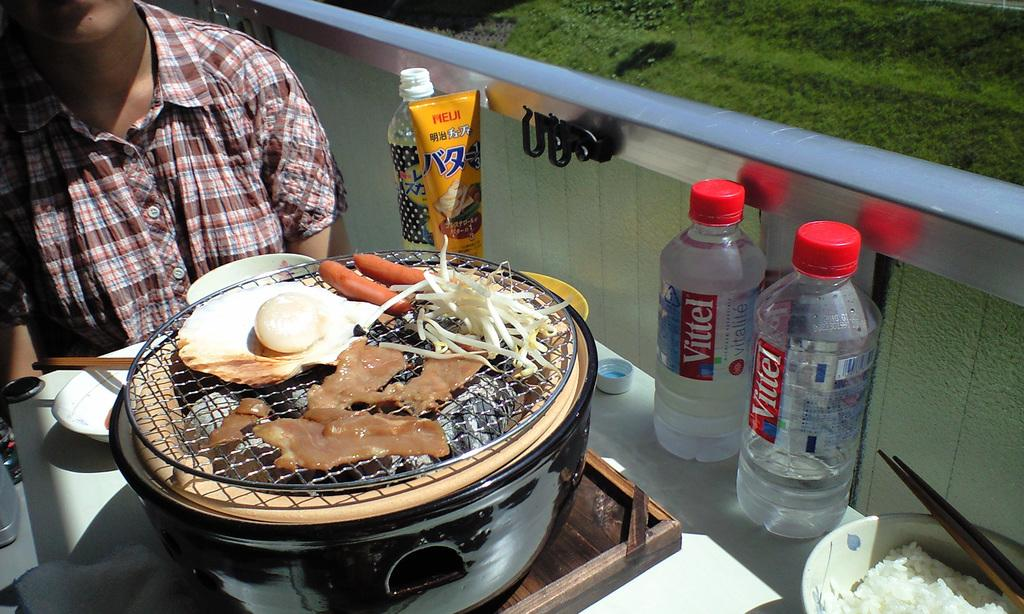<image>
Share a concise interpretation of the image provided. A small grill cooking up food next to some Asian condiments and bottles of Vittel. 